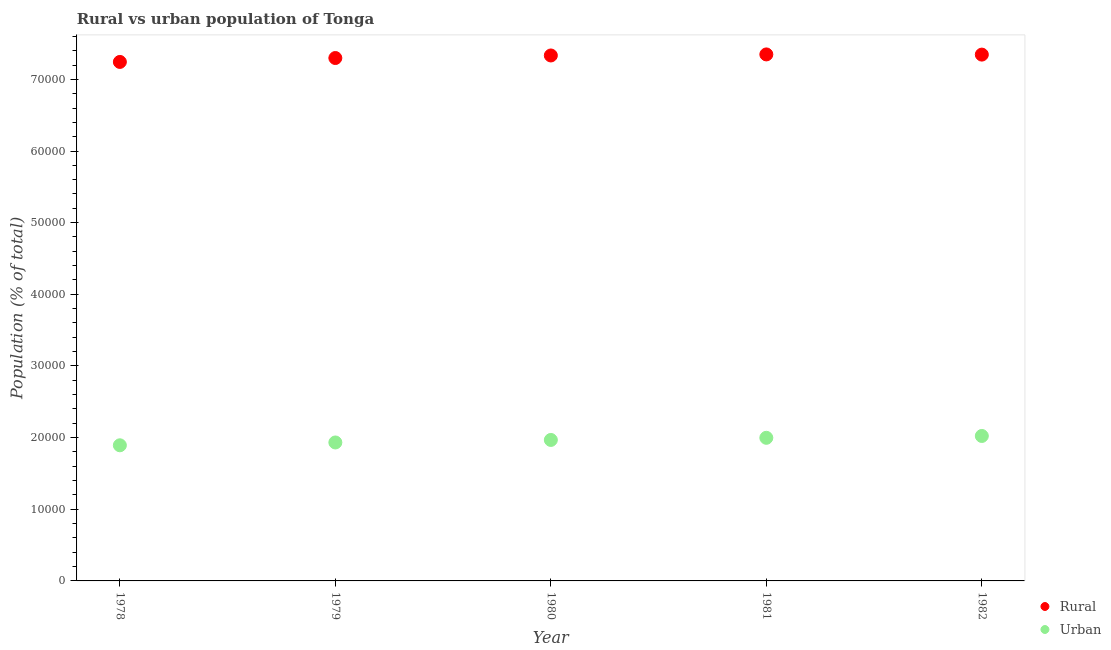What is the rural population density in 1978?
Make the answer very short. 7.24e+04. Across all years, what is the maximum urban population density?
Offer a very short reply. 2.02e+04. Across all years, what is the minimum rural population density?
Give a very brief answer. 7.24e+04. In which year was the urban population density maximum?
Provide a succinct answer. 1982. In which year was the rural population density minimum?
Give a very brief answer. 1978. What is the total urban population density in the graph?
Offer a terse response. 9.81e+04. What is the difference between the rural population density in 1980 and that in 1982?
Make the answer very short. -121. What is the difference between the urban population density in 1982 and the rural population density in 1980?
Your answer should be very brief. -5.31e+04. What is the average urban population density per year?
Offer a terse response. 1.96e+04. In the year 1980, what is the difference between the rural population density and urban population density?
Your answer should be compact. 5.37e+04. What is the ratio of the rural population density in 1981 to that in 1982?
Provide a short and direct response. 1. What is the difference between the highest and the second highest rural population density?
Offer a terse response. 26. What is the difference between the highest and the lowest urban population density?
Your response must be concise. 1301. Is the rural population density strictly greater than the urban population density over the years?
Your answer should be very brief. Yes. Is the rural population density strictly less than the urban population density over the years?
Make the answer very short. No. How many dotlines are there?
Make the answer very short. 2. How many years are there in the graph?
Your response must be concise. 5. What is the difference between two consecutive major ticks on the Y-axis?
Offer a terse response. 10000. Are the values on the major ticks of Y-axis written in scientific E-notation?
Offer a very short reply. No. Does the graph contain any zero values?
Give a very brief answer. No. Does the graph contain grids?
Offer a very short reply. No. What is the title of the graph?
Provide a short and direct response. Rural vs urban population of Tonga. What is the label or title of the X-axis?
Provide a short and direct response. Year. What is the label or title of the Y-axis?
Provide a short and direct response. Population (% of total). What is the Population (% of total) of Rural in 1978?
Ensure brevity in your answer.  7.24e+04. What is the Population (% of total) in Urban in 1978?
Give a very brief answer. 1.89e+04. What is the Population (% of total) of Rural in 1979?
Your answer should be very brief. 7.30e+04. What is the Population (% of total) in Urban in 1979?
Give a very brief answer. 1.93e+04. What is the Population (% of total) in Rural in 1980?
Your answer should be compact. 7.33e+04. What is the Population (% of total) in Urban in 1980?
Your answer should be very brief. 1.97e+04. What is the Population (% of total) in Rural in 1981?
Give a very brief answer. 7.35e+04. What is the Population (% of total) in Urban in 1981?
Offer a very short reply. 2.00e+04. What is the Population (% of total) in Rural in 1982?
Make the answer very short. 7.35e+04. What is the Population (% of total) in Urban in 1982?
Your response must be concise. 2.02e+04. Across all years, what is the maximum Population (% of total) in Rural?
Give a very brief answer. 7.35e+04. Across all years, what is the maximum Population (% of total) in Urban?
Offer a very short reply. 2.02e+04. Across all years, what is the minimum Population (% of total) of Rural?
Offer a very short reply. 7.24e+04. Across all years, what is the minimum Population (% of total) in Urban?
Your answer should be compact. 1.89e+04. What is the total Population (% of total) in Rural in the graph?
Offer a terse response. 3.66e+05. What is the total Population (% of total) in Urban in the graph?
Provide a short and direct response. 9.81e+04. What is the difference between the Population (% of total) in Rural in 1978 and that in 1979?
Make the answer very short. -545. What is the difference between the Population (% of total) of Urban in 1978 and that in 1979?
Your answer should be very brief. -394. What is the difference between the Population (% of total) in Rural in 1978 and that in 1980?
Give a very brief answer. -901. What is the difference between the Population (% of total) in Urban in 1978 and that in 1980?
Give a very brief answer. -746. What is the difference between the Population (% of total) of Rural in 1978 and that in 1981?
Keep it short and to the point. -1048. What is the difference between the Population (% of total) in Urban in 1978 and that in 1981?
Your response must be concise. -1044. What is the difference between the Population (% of total) of Rural in 1978 and that in 1982?
Offer a very short reply. -1022. What is the difference between the Population (% of total) of Urban in 1978 and that in 1982?
Provide a short and direct response. -1301. What is the difference between the Population (% of total) in Rural in 1979 and that in 1980?
Give a very brief answer. -356. What is the difference between the Population (% of total) in Urban in 1979 and that in 1980?
Your response must be concise. -352. What is the difference between the Population (% of total) of Rural in 1979 and that in 1981?
Your answer should be very brief. -503. What is the difference between the Population (% of total) in Urban in 1979 and that in 1981?
Give a very brief answer. -650. What is the difference between the Population (% of total) in Rural in 1979 and that in 1982?
Keep it short and to the point. -477. What is the difference between the Population (% of total) of Urban in 1979 and that in 1982?
Give a very brief answer. -907. What is the difference between the Population (% of total) of Rural in 1980 and that in 1981?
Your response must be concise. -147. What is the difference between the Population (% of total) in Urban in 1980 and that in 1981?
Offer a terse response. -298. What is the difference between the Population (% of total) of Rural in 1980 and that in 1982?
Ensure brevity in your answer.  -121. What is the difference between the Population (% of total) of Urban in 1980 and that in 1982?
Make the answer very short. -555. What is the difference between the Population (% of total) in Urban in 1981 and that in 1982?
Make the answer very short. -257. What is the difference between the Population (% of total) of Rural in 1978 and the Population (% of total) of Urban in 1979?
Ensure brevity in your answer.  5.31e+04. What is the difference between the Population (% of total) of Rural in 1978 and the Population (% of total) of Urban in 1980?
Keep it short and to the point. 5.28e+04. What is the difference between the Population (% of total) of Rural in 1978 and the Population (% of total) of Urban in 1981?
Keep it short and to the point. 5.25e+04. What is the difference between the Population (% of total) in Rural in 1978 and the Population (% of total) in Urban in 1982?
Give a very brief answer. 5.22e+04. What is the difference between the Population (% of total) in Rural in 1979 and the Population (% of total) in Urban in 1980?
Offer a terse response. 5.33e+04. What is the difference between the Population (% of total) of Rural in 1979 and the Population (% of total) of Urban in 1981?
Give a very brief answer. 5.30e+04. What is the difference between the Population (% of total) in Rural in 1979 and the Population (% of total) in Urban in 1982?
Ensure brevity in your answer.  5.27e+04. What is the difference between the Population (% of total) of Rural in 1980 and the Population (% of total) of Urban in 1981?
Offer a very short reply. 5.34e+04. What is the difference between the Population (% of total) of Rural in 1980 and the Population (% of total) of Urban in 1982?
Your response must be concise. 5.31e+04. What is the difference between the Population (% of total) in Rural in 1981 and the Population (% of total) in Urban in 1982?
Ensure brevity in your answer.  5.32e+04. What is the average Population (% of total) in Rural per year?
Ensure brevity in your answer.  7.31e+04. What is the average Population (% of total) of Urban per year?
Keep it short and to the point. 1.96e+04. In the year 1978, what is the difference between the Population (% of total) in Rural and Population (% of total) in Urban?
Provide a succinct answer. 5.35e+04. In the year 1979, what is the difference between the Population (% of total) in Rural and Population (% of total) in Urban?
Your answer should be very brief. 5.37e+04. In the year 1980, what is the difference between the Population (% of total) of Rural and Population (% of total) of Urban?
Offer a very short reply. 5.37e+04. In the year 1981, what is the difference between the Population (% of total) in Rural and Population (% of total) in Urban?
Provide a short and direct response. 5.35e+04. In the year 1982, what is the difference between the Population (% of total) in Rural and Population (% of total) in Urban?
Offer a terse response. 5.32e+04. What is the ratio of the Population (% of total) of Urban in 1978 to that in 1979?
Offer a very short reply. 0.98. What is the ratio of the Population (% of total) of Urban in 1978 to that in 1980?
Offer a terse response. 0.96. What is the ratio of the Population (% of total) of Rural in 1978 to that in 1981?
Your response must be concise. 0.99. What is the ratio of the Population (% of total) of Urban in 1978 to that in 1981?
Provide a short and direct response. 0.95. What is the ratio of the Population (% of total) of Rural in 1978 to that in 1982?
Offer a very short reply. 0.99. What is the ratio of the Population (% of total) in Urban in 1978 to that in 1982?
Your answer should be compact. 0.94. What is the ratio of the Population (% of total) of Urban in 1979 to that in 1980?
Provide a succinct answer. 0.98. What is the ratio of the Population (% of total) in Rural in 1979 to that in 1981?
Make the answer very short. 0.99. What is the ratio of the Population (% of total) of Urban in 1979 to that in 1981?
Your answer should be very brief. 0.97. What is the ratio of the Population (% of total) in Rural in 1979 to that in 1982?
Give a very brief answer. 0.99. What is the ratio of the Population (% of total) of Urban in 1979 to that in 1982?
Give a very brief answer. 0.96. What is the ratio of the Population (% of total) of Rural in 1980 to that in 1981?
Give a very brief answer. 1. What is the ratio of the Population (% of total) in Urban in 1980 to that in 1981?
Your answer should be very brief. 0.99. What is the ratio of the Population (% of total) of Urban in 1980 to that in 1982?
Provide a succinct answer. 0.97. What is the ratio of the Population (% of total) of Urban in 1981 to that in 1982?
Provide a succinct answer. 0.99. What is the difference between the highest and the second highest Population (% of total) in Rural?
Your response must be concise. 26. What is the difference between the highest and the second highest Population (% of total) in Urban?
Make the answer very short. 257. What is the difference between the highest and the lowest Population (% of total) in Rural?
Keep it short and to the point. 1048. What is the difference between the highest and the lowest Population (% of total) in Urban?
Ensure brevity in your answer.  1301. 